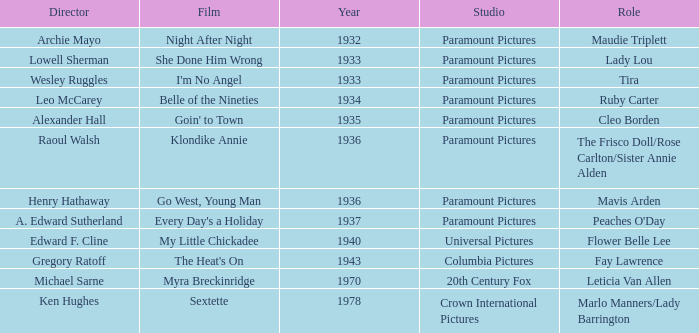What is the Year of the Film Belle of the Nineties? 1934.0. 